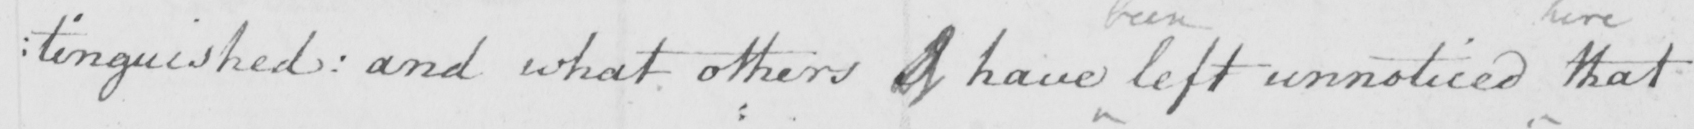Please provide the text content of this handwritten line. : tinguished and what others of have left unnoticed that 